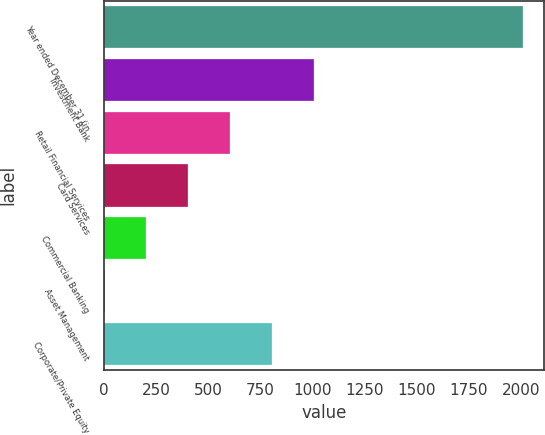Convert chart to OTSL. <chart><loc_0><loc_0><loc_500><loc_500><bar_chart><fcel>Year ended December 31 (in<fcel>Investment Bank<fcel>Retail Financial Services<fcel>Card Services<fcel>Commercial Banking<fcel>Asset Management<fcel>Corporate/Private Equity<nl><fcel>2008<fcel>1005.5<fcel>604.5<fcel>404<fcel>203.5<fcel>3<fcel>805<nl></chart> 